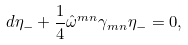<formula> <loc_0><loc_0><loc_500><loc_500>d \eta _ { - } + \frac { 1 } { 4 } \hat { \omega } ^ { m n } \gamma _ { m n } \eta _ { - } = 0 ,</formula> 